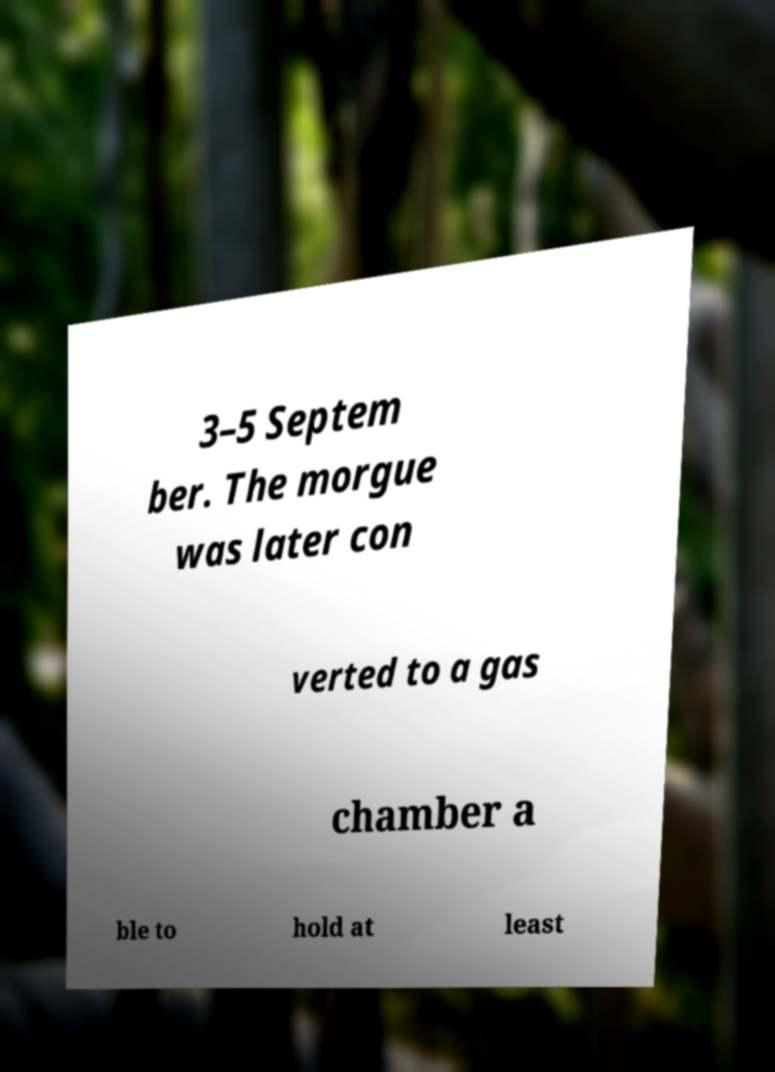I need the written content from this picture converted into text. Can you do that? 3–5 Septem ber. The morgue was later con verted to a gas chamber a ble to hold at least 